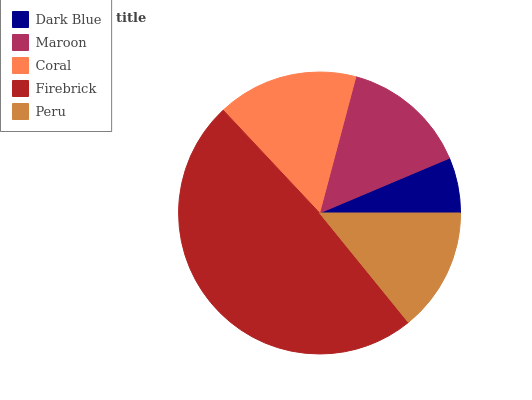Is Dark Blue the minimum?
Answer yes or no. Yes. Is Firebrick the maximum?
Answer yes or no. Yes. Is Maroon the minimum?
Answer yes or no. No. Is Maroon the maximum?
Answer yes or no. No. Is Maroon greater than Dark Blue?
Answer yes or no. Yes. Is Dark Blue less than Maroon?
Answer yes or no. Yes. Is Dark Blue greater than Maroon?
Answer yes or no. No. Is Maroon less than Dark Blue?
Answer yes or no. No. Is Maroon the high median?
Answer yes or no. Yes. Is Maroon the low median?
Answer yes or no. Yes. Is Peru the high median?
Answer yes or no. No. Is Coral the low median?
Answer yes or no. No. 